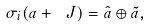Convert formula to latex. <formula><loc_0><loc_0><loc_500><loc_500>\sigma _ { i } ( a + \ J ) = \hat { a } \oplus \tilde { a } ,</formula> 